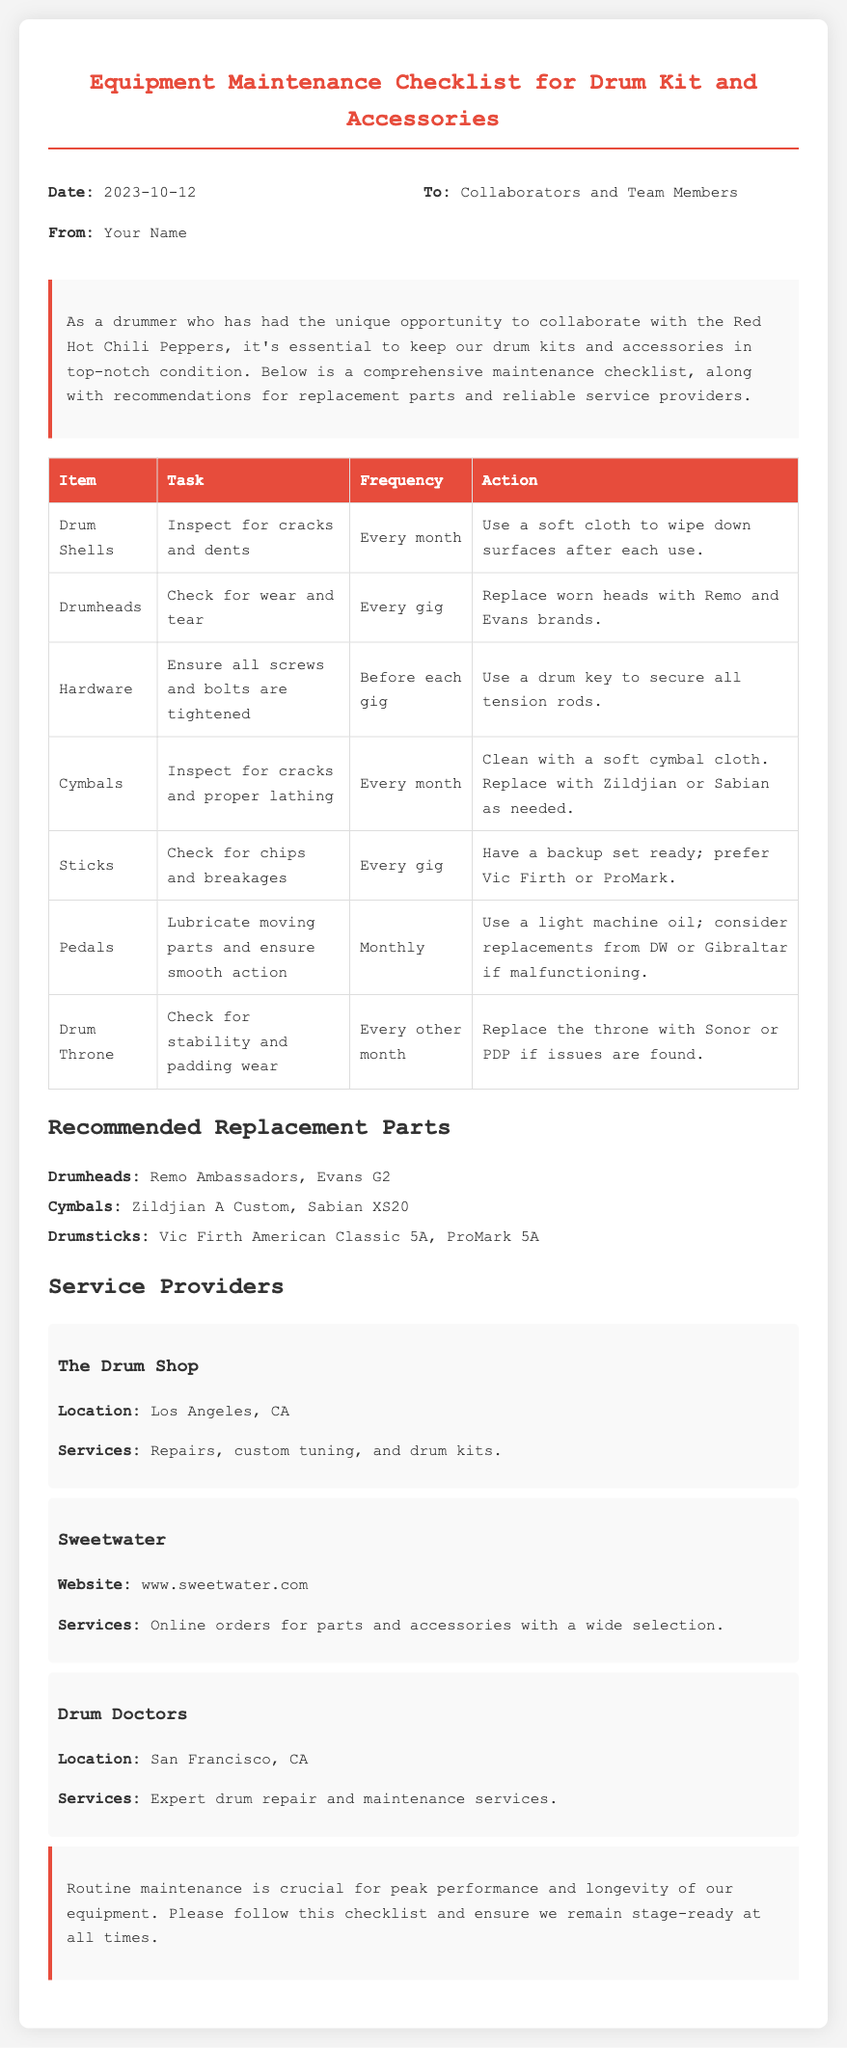What is the date of the memo? The date of the memo is mentioned in the header section as "2023-10-12."
Answer: 2023-10-12 Who is the memo addressed to? The memo is addressed to "Collaborators and Team Members."
Answer: Collaborators and Team Members How often should the drum shells be inspected? The frequency for inspecting drum shells is stated as "Every month."
Answer: Every month What brand of drumheads is recommended for replacement? The document mentions "Remo and Evans brands" as the recommended brands for drumheads.
Answer: Remo and Evans What is the location of The Drum Shop? The location of The Drum Shop is specified as "Los Angeles, CA."
Answer: Los Angeles, CA Which accessory should be checked for stability and padding wear? The document specifies that the drum throne should be checked for stability and padding wear.
Answer: Drum Throne What services are provided by Drum Doctors? The services offered by Drum Doctors include "Expert drum repair and maintenance services."
Answer: Expert drum repair and maintenance services How frequently should the pedals be lubricated? The frequency for lubricating the pedals is noted as "Monthly."
Answer: Monthly What should be done before each gig regarding hardware? The action required before each gig is to "Ensure all screws and bolts are tightened."
Answer: Ensure all screws and bolts are tightened 